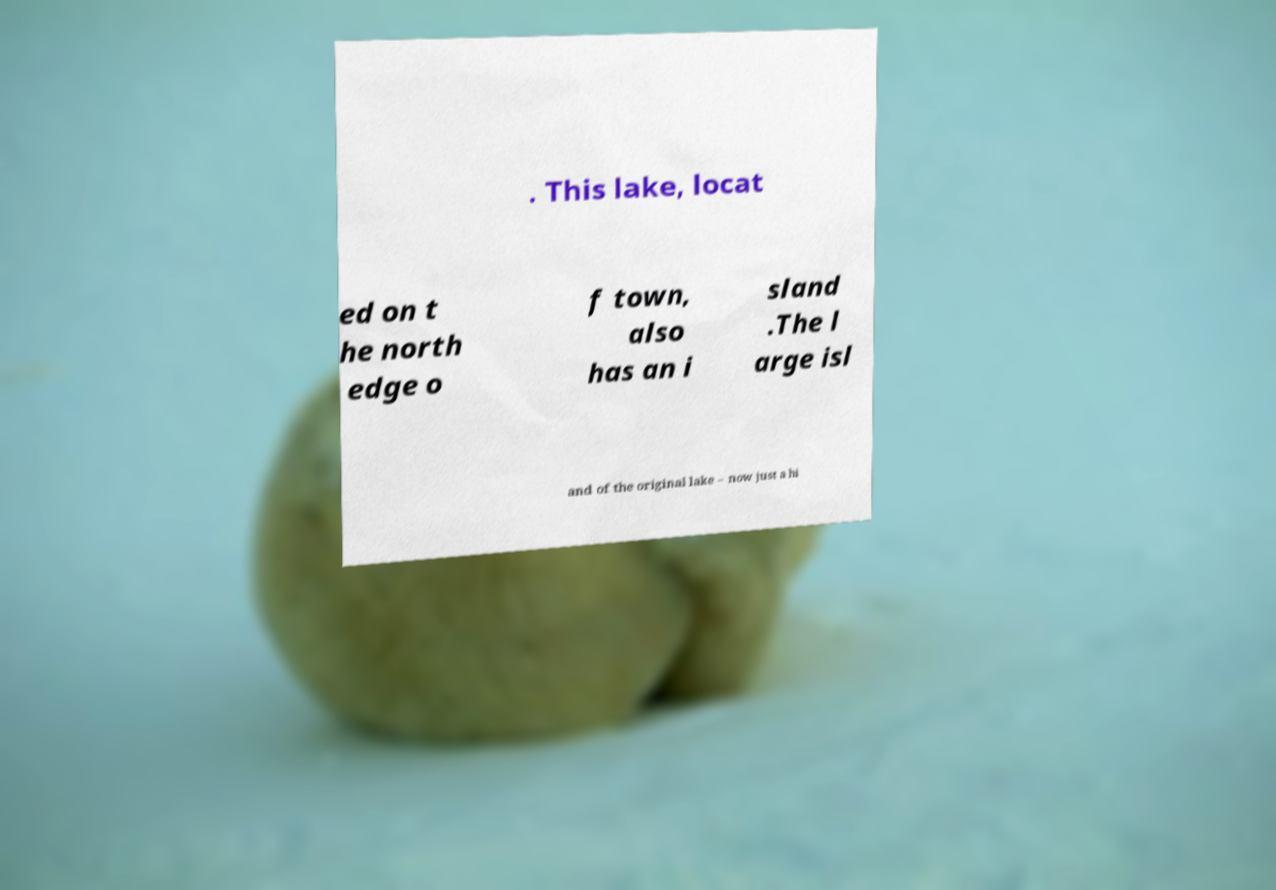There's text embedded in this image that I need extracted. Can you transcribe it verbatim? . This lake, locat ed on t he north edge o f town, also has an i sland .The l arge isl and of the original lake – now just a hi 